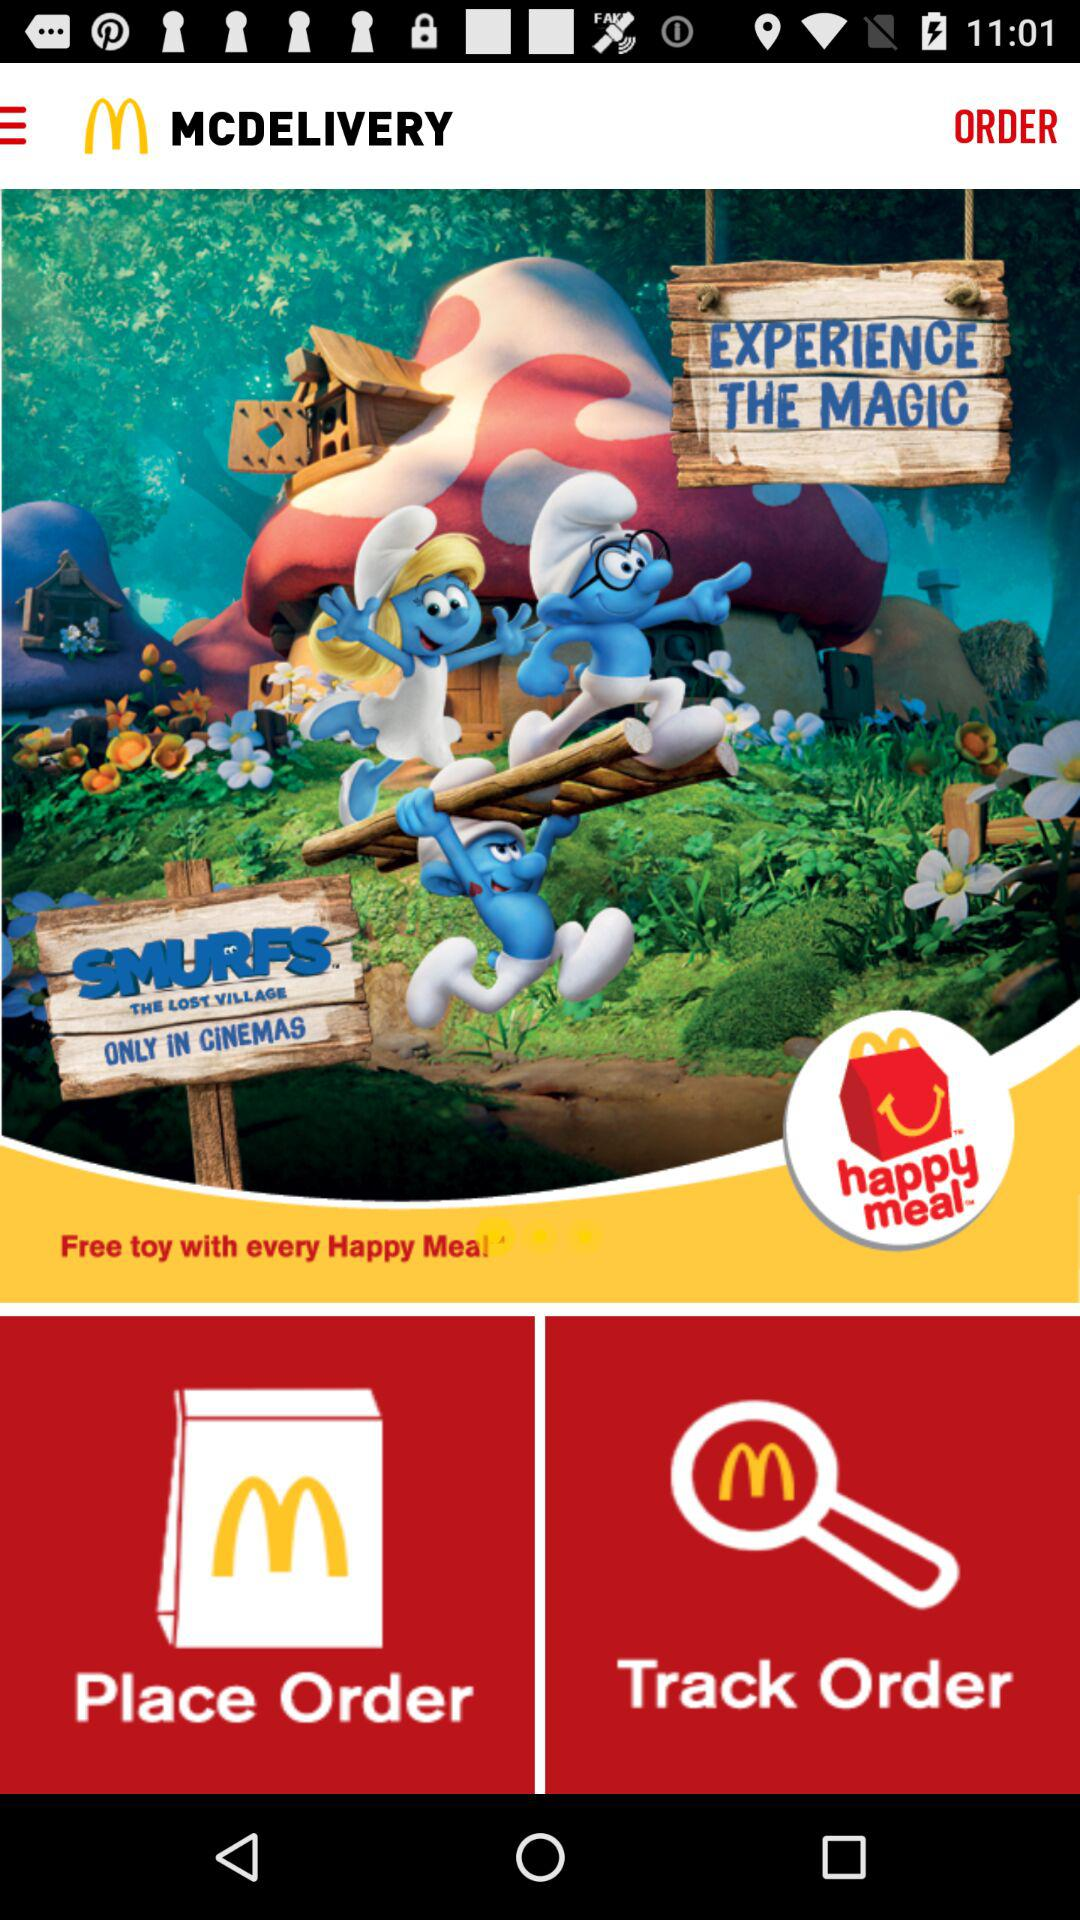What will we get with every Happy Meal? You will get the free toy with every Happy Meal. 